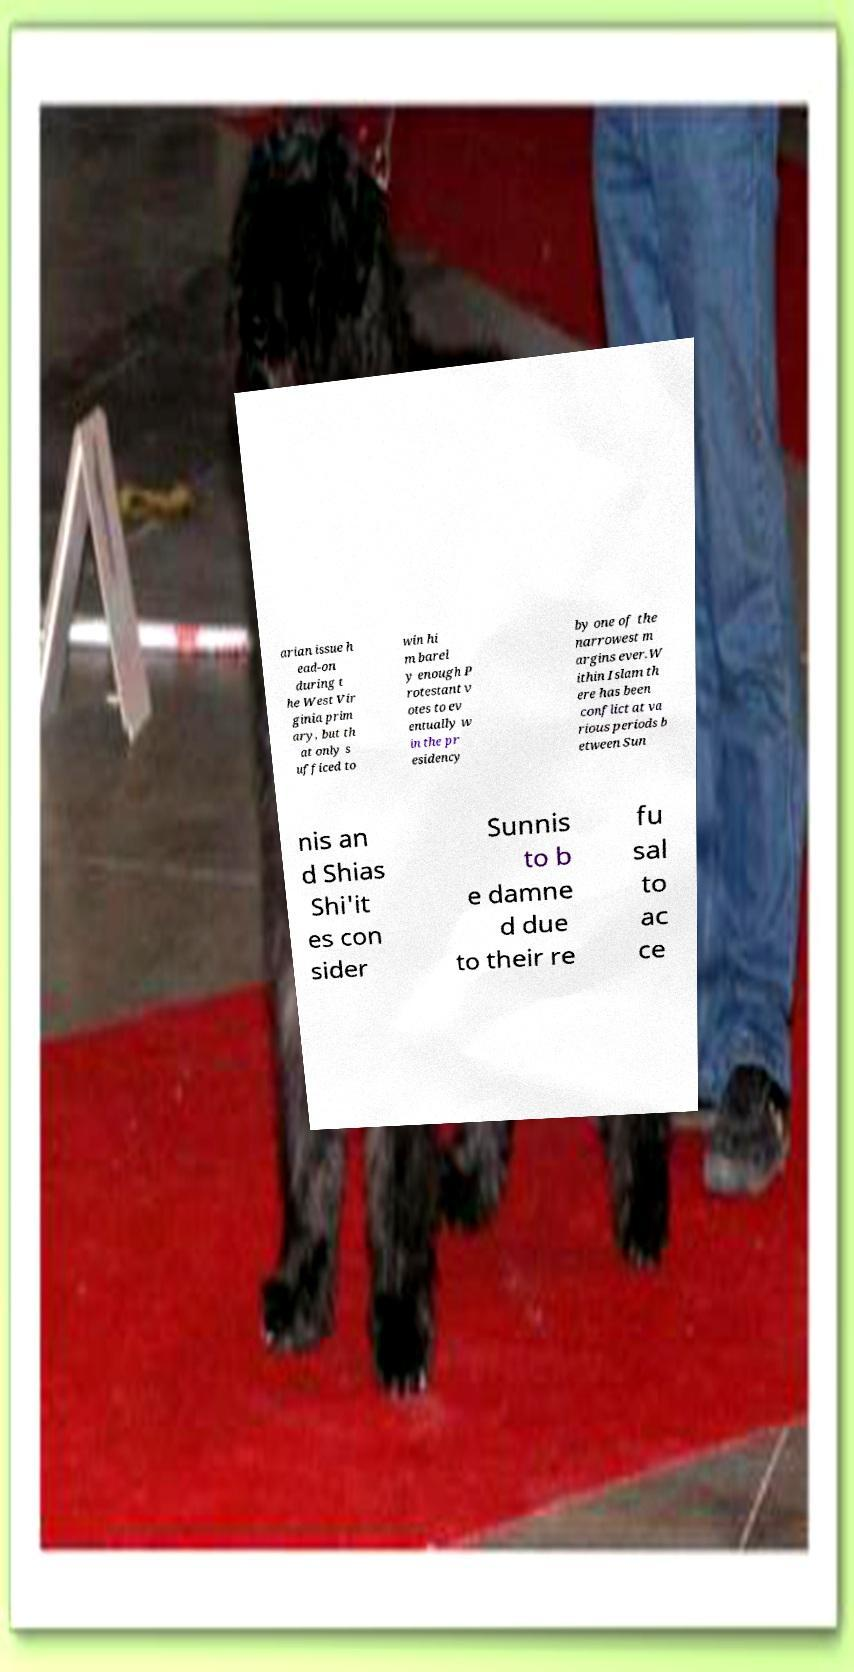There's text embedded in this image that I need extracted. Can you transcribe it verbatim? arian issue h ead-on during t he West Vir ginia prim ary, but th at only s ufficed to win hi m barel y enough P rotestant v otes to ev entually w in the pr esidency by one of the narrowest m argins ever.W ithin Islam th ere has been conflict at va rious periods b etween Sun nis an d Shias Shi'it es con sider Sunnis to b e damne d due to their re fu sal to ac ce 